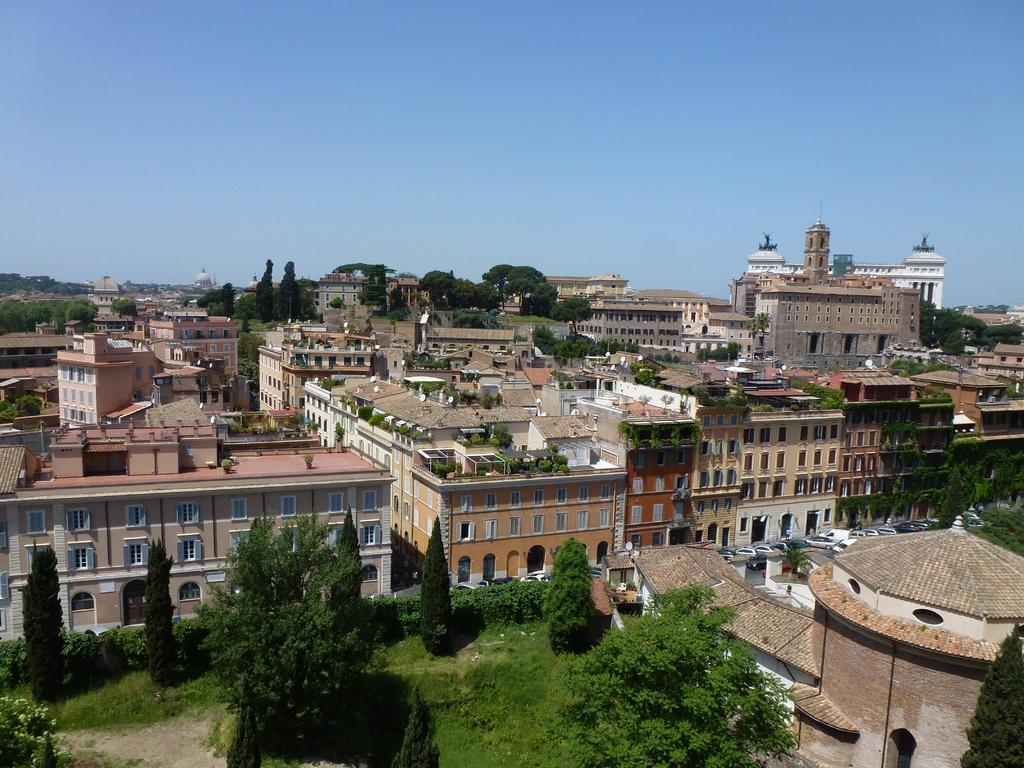What types of structures are present in the image? There are multiple buildings in the image. What type of vegetation can be seen in the image? There are multiple trees in the image. What type of transportation is visible in the image? There are multiple vehicles in the image. What type of ground surface is visible in the image? Grass is visible in the image. What is visible in the background of the image? The sky is visible in the background of the image. Can you tell me how many jellyfish are swimming in the grass in the image? There are no jellyfish present in the image; it features buildings, trees, vehicles, grass, and the sky. What type of lock is securing the buildings in the image? There is no lock visible in the image; it only shows buildings, trees, vehicles, grass, and the sky. 